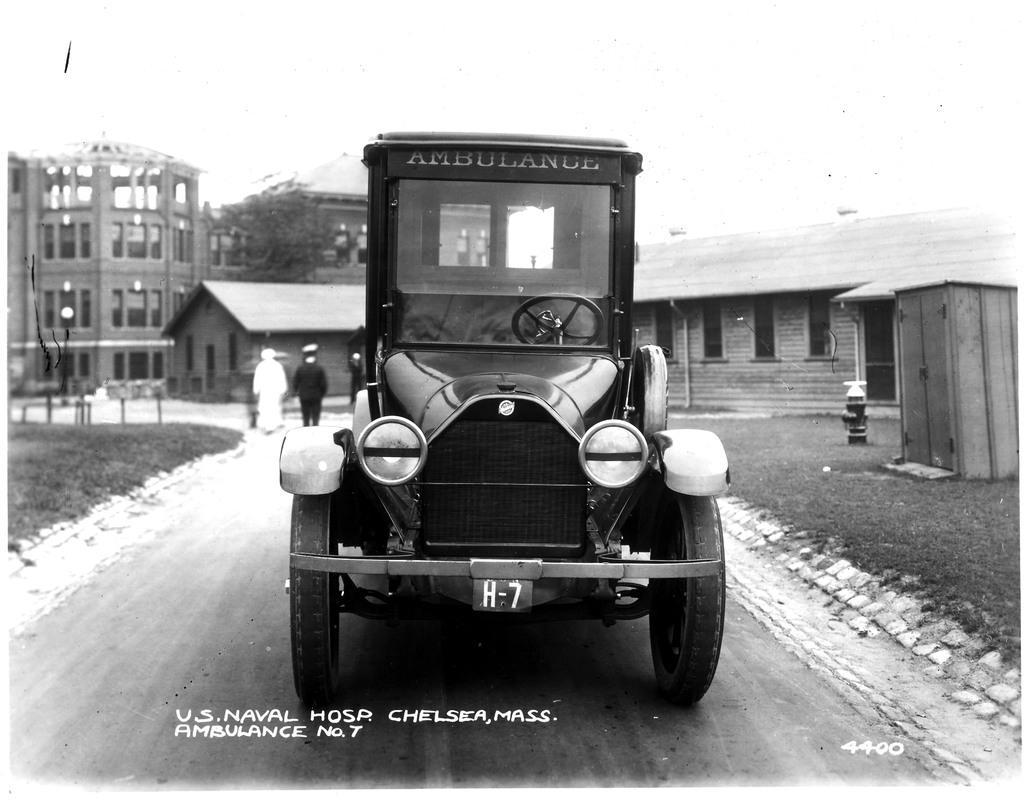Can you describe this image briefly? This is a black and white image. There is a vehicle and 2 people are present behind it. There are buildings at the back. 